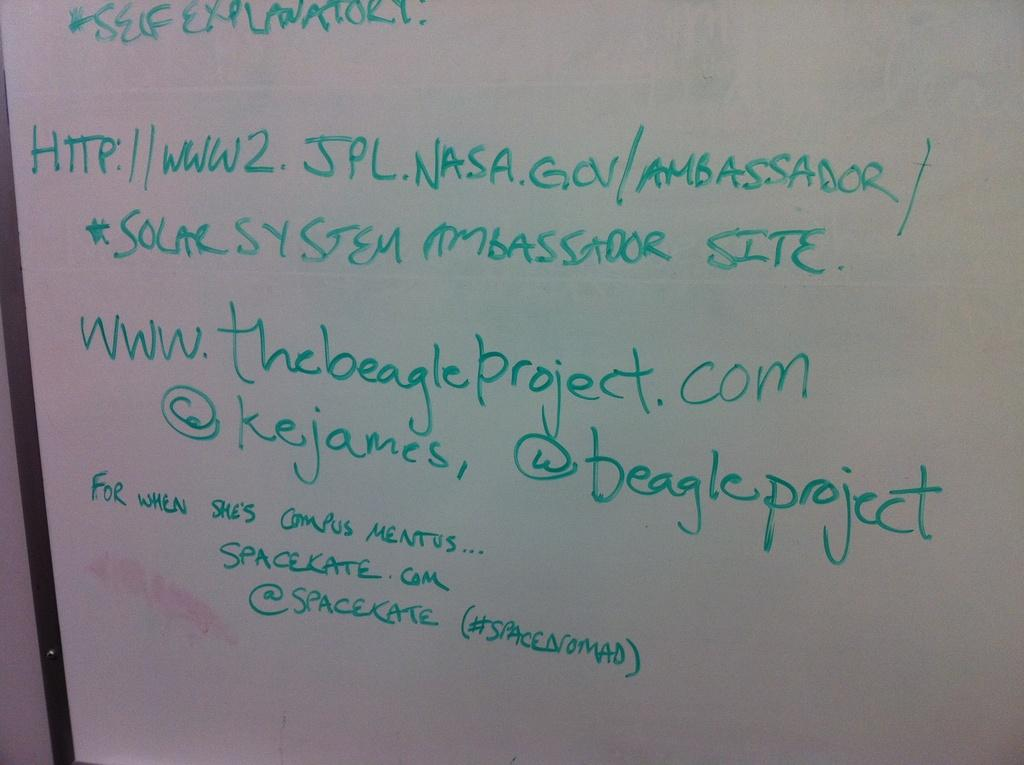<image>
Summarize the visual content of the image. Handwriting on a dry erase board gives the URL to the solar system ambassador site. 